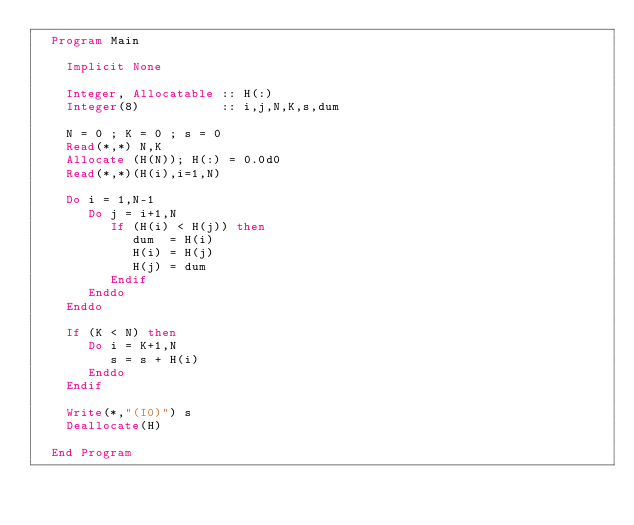Convert code to text. <code><loc_0><loc_0><loc_500><loc_500><_FORTRAN_>  Program Main

    Implicit None

    Integer, Allocatable :: H(:) 
    Integer(8)           :: i,j,N,K,s,dum

    N = 0 ; K = 0 ; s = 0
    Read(*,*) N,K
    Allocate (H(N)); H(:) = 0.0d0 
    Read(*,*)(H(i),i=1,N)

    Do i = 1,N-1
       Do j = i+1,N
          If (H(i) < H(j)) then
             dum  = H(i)
             H(i) = H(j)
             H(j) = dum
          Endif
       Enddo
    Enddo

    If (K < N) then
       Do i = K+1,N
          s = s + H(i)
       Enddo
    Endif

    Write(*,"(I0)") s
    Deallocate(H)

  End Program
</code> 